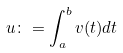<formula> <loc_0><loc_0><loc_500><loc_500>u \colon = \int _ { a } ^ { b } v ( t ) d t</formula> 